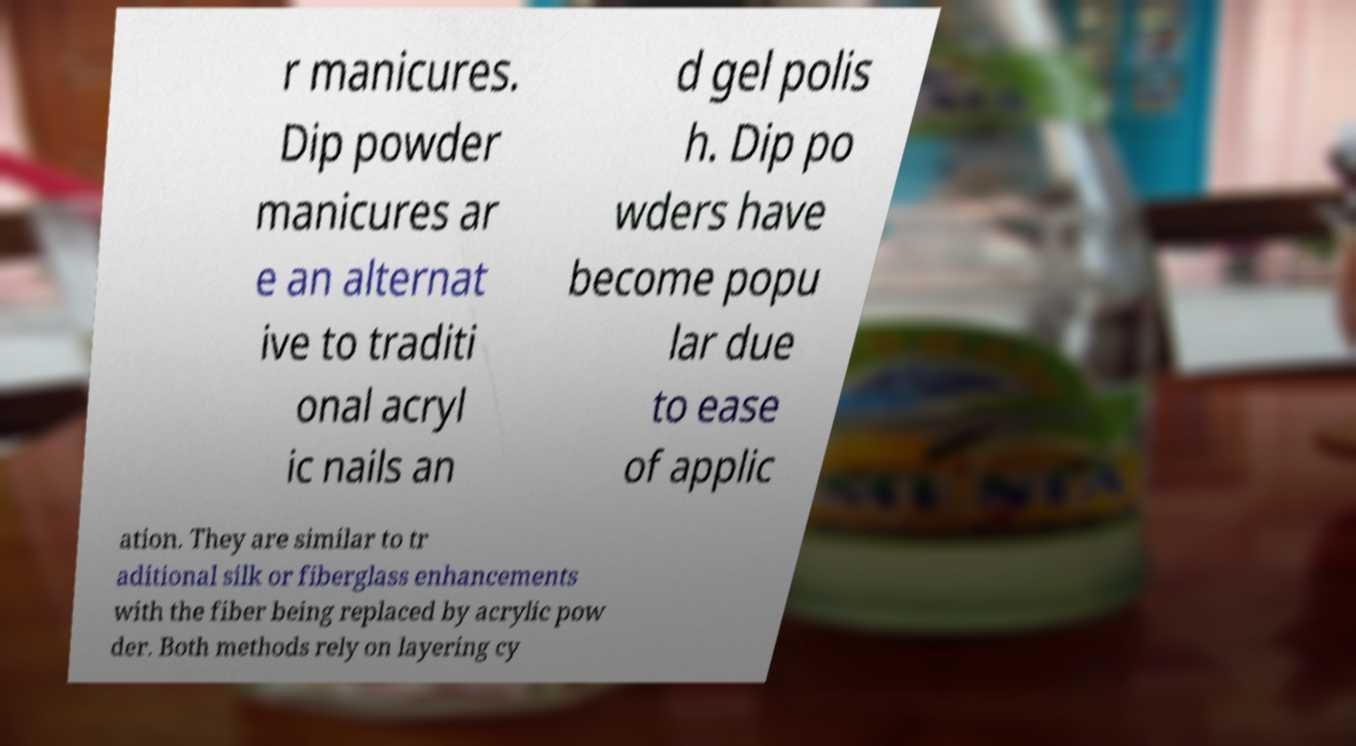For documentation purposes, I need the text within this image transcribed. Could you provide that? r manicures. Dip powder manicures ar e an alternat ive to traditi onal acryl ic nails an d gel polis h. Dip po wders have become popu lar due to ease of applic ation. They are similar to tr aditional silk or fiberglass enhancements with the fiber being replaced by acrylic pow der. Both methods rely on layering cy 